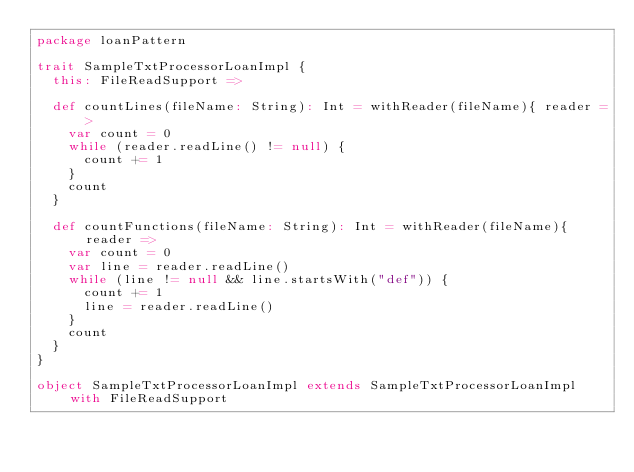<code> <loc_0><loc_0><loc_500><loc_500><_Scala_>package loanPattern

trait SampleTxtProcessorLoanImpl {
  this: FileReadSupport =>

  def countLines(fileName: String): Int = withReader(fileName){ reader =>
    var count = 0
    while (reader.readLine() != null) {
      count += 1
    }
    count
  }

  def countFunctions(fileName: String): Int = withReader(fileName){ reader =>
    var count = 0
    var line = reader.readLine()
    while (line != null && line.startsWith("def")) {
      count += 1
      line = reader.readLine()
    }
    count
  }
}

object SampleTxtProcessorLoanImpl extends SampleTxtProcessorLoanImpl with FileReadSupport
</code> 